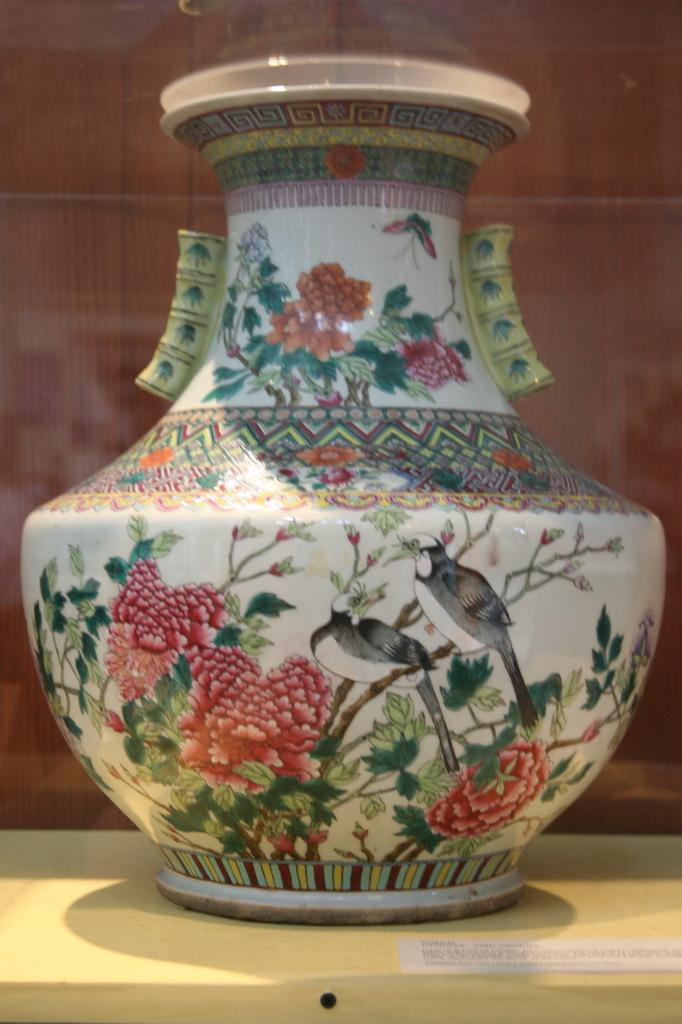What is the main object in the center of the image? There is a pot in the center of the image. What is located at the bottom of the image? There is a table at the bottom of the image. What type of wall can be seen in the background of the image? There is a wooden wall in the background of the image. What channel is the pot being used on in the image? There is no reference to a channel or any television-related activity in the image, so it's not possible to determine which channel the pot might be associated with. 